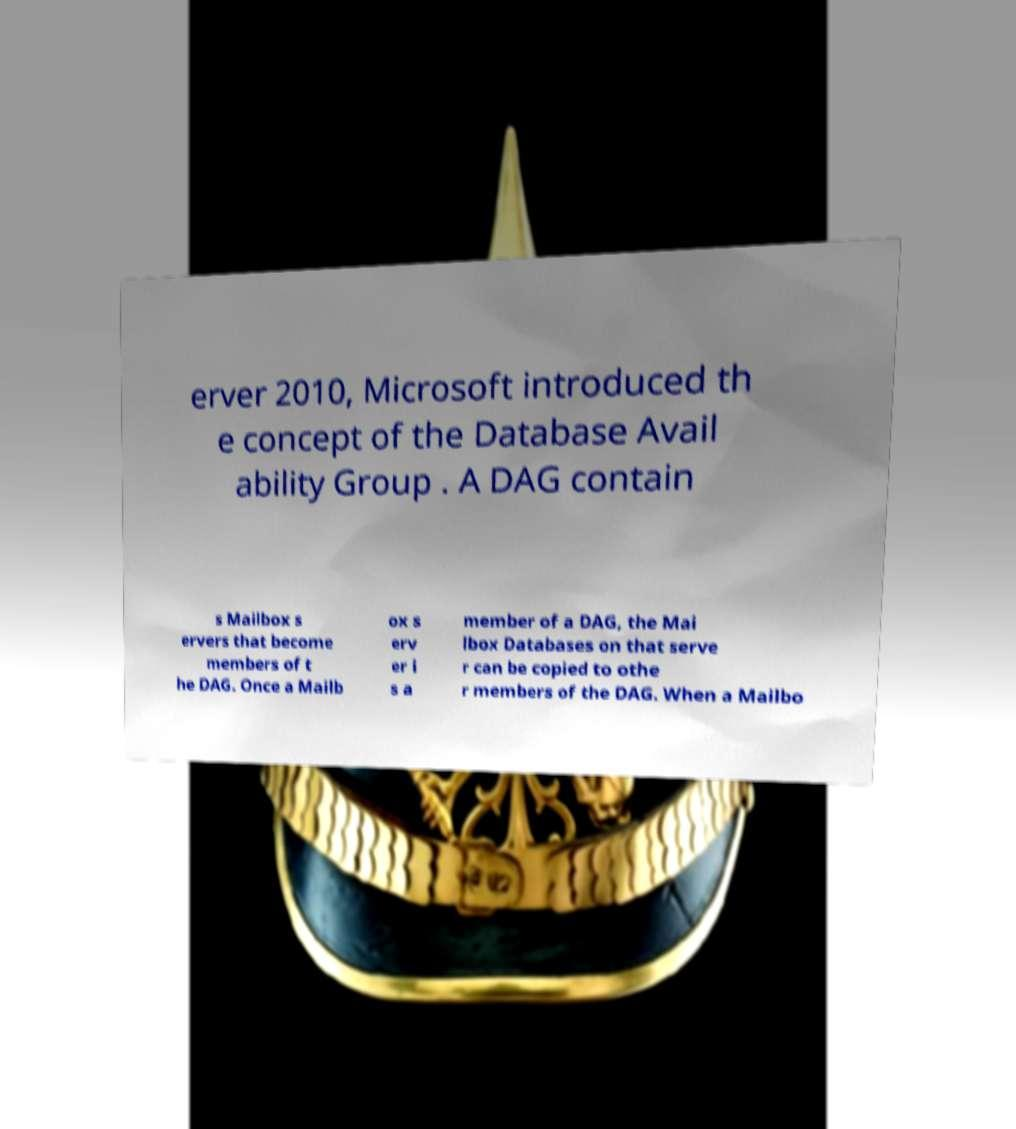Can you accurately transcribe the text from the provided image for me? erver 2010, Microsoft introduced th e concept of the Database Avail ability Group . A DAG contain s Mailbox s ervers that become members of t he DAG. Once a Mailb ox s erv er i s a member of a DAG, the Mai lbox Databases on that serve r can be copied to othe r members of the DAG. When a Mailbo 